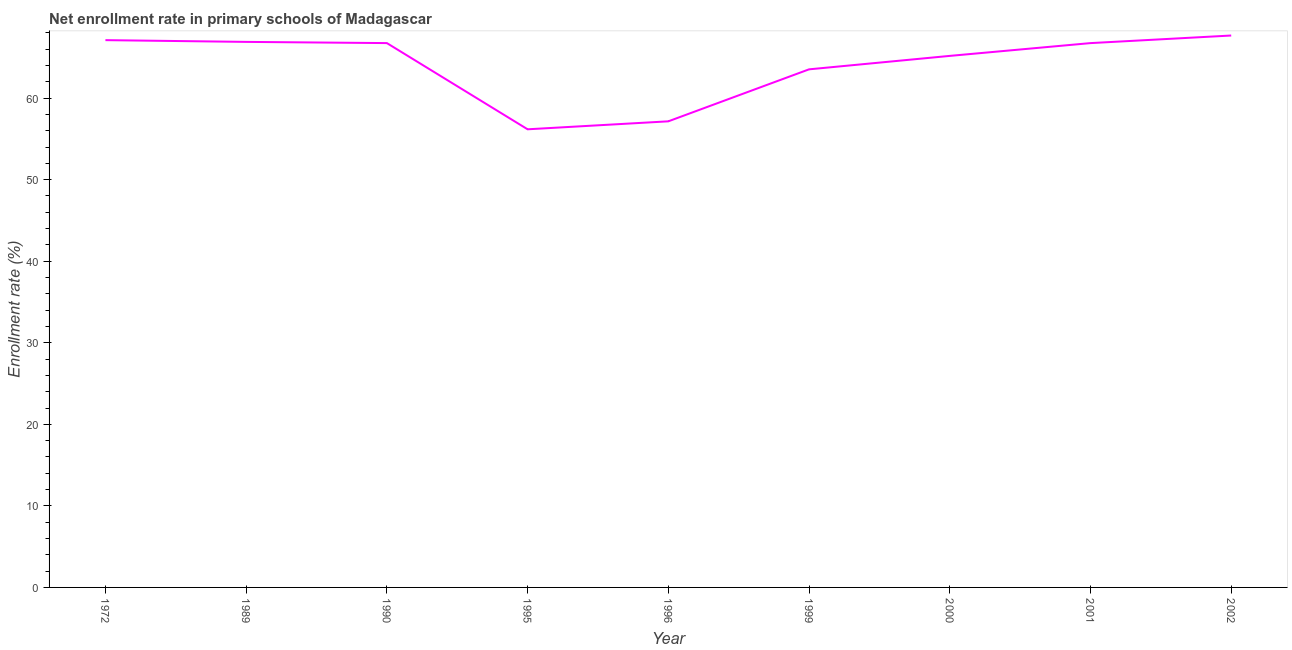What is the net enrollment rate in primary schools in 2001?
Keep it short and to the point. 66.75. Across all years, what is the maximum net enrollment rate in primary schools?
Keep it short and to the point. 67.68. Across all years, what is the minimum net enrollment rate in primary schools?
Provide a short and direct response. 56.18. What is the sum of the net enrollment rate in primary schools?
Provide a succinct answer. 577.24. What is the difference between the net enrollment rate in primary schools in 1990 and 2000?
Give a very brief answer. 1.57. What is the average net enrollment rate in primary schools per year?
Provide a short and direct response. 64.14. What is the median net enrollment rate in primary schools?
Your answer should be compact. 66.75. In how many years, is the net enrollment rate in primary schools greater than 10 %?
Offer a terse response. 9. Do a majority of the years between 2001 and 1999 (inclusive) have net enrollment rate in primary schools greater than 30 %?
Your response must be concise. No. What is the ratio of the net enrollment rate in primary schools in 1996 to that in 2000?
Make the answer very short. 0.88. What is the difference between the highest and the second highest net enrollment rate in primary schools?
Ensure brevity in your answer.  0.57. Is the sum of the net enrollment rate in primary schools in 1990 and 1999 greater than the maximum net enrollment rate in primary schools across all years?
Provide a short and direct response. Yes. What is the difference between the highest and the lowest net enrollment rate in primary schools?
Provide a succinct answer. 11.5. How many lines are there?
Your response must be concise. 1. How many years are there in the graph?
Offer a terse response. 9. Are the values on the major ticks of Y-axis written in scientific E-notation?
Ensure brevity in your answer.  No. Does the graph contain grids?
Keep it short and to the point. No. What is the title of the graph?
Give a very brief answer. Net enrollment rate in primary schools of Madagascar. What is the label or title of the X-axis?
Your answer should be compact. Year. What is the label or title of the Y-axis?
Give a very brief answer. Enrollment rate (%). What is the Enrollment rate (%) in 1972?
Your answer should be very brief. 67.11. What is the Enrollment rate (%) of 1989?
Your answer should be compact. 66.9. What is the Enrollment rate (%) of 1990?
Provide a succinct answer. 66.75. What is the Enrollment rate (%) in 1995?
Offer a very short reply. 56.18. What is the Enrollment rate (%) in 1996?
Make the answer very short. 57.16. What is the Enrollment rate (%) in 1999?
Provide a succinct answer. 63.53. What is the Enrollment rate (%) in 2000?
Give a very brief answer. 65.18. What is the Enrollment rate (%) of 2001?
Keep it short and to the point. 66.75. What is the Enrollment rate (%) in 2002?
Your response must be concise. 67.68. What is the difference between the Enrollment rate (%) in 1972 and 1989?
Provide a succinct answer. 0.21. What is the difference between the Enrollment rate (%) in 1972 and 1990?
Your response must be concise. 0.36. What is the difference between the Enrollment rate (%) in 1972 and 1995?
Your answer should be compact. 10.93. What is the difference between the Enrollment rate (%) in 1972 and 1996?
Provide a short and direct response. 9.95. What is the difference between the Enrollment rate (%) in 1972 and 1999?
Provide a succinct answer. 3.58. What is the difference between the Enrollment rate (%) in 1972 and 2000?
Provide a succinct answer. 1.93. What is the difference between the Enrollment rate (%) in 1972 and 2001?
Provide a short and direct response. 0.36. What is the difference between the Enrollment rate (%) in 1972 and 2002?
Make the answer very short. -0.57. What is the difference between the Enrollment rate (%) in 1989 and 1990?
Offer a terse response. 0.15. What is the difference between the Enrollment rate (%) in 1989 and 1995?
Your answer should be compact. 10.72. What is the difference between the Enrollment rate (%) in 1989 and 1996?
Offer a very short reply. 9.74. What is the difference between the Enrollment rate (%) in 1989 and 1999?
Offer a terse response. 3.37. What is the difference between the Enrollment rate (%) in 1989 and 2000?
Provide a short and direct response. 1.72. What is the difference between the Enrollment rate (%) in 1989 and 2001?
Offer a very short reply. 0.15. What is the difference between the Enrollment rate (%) in 1989 and 2002?
Offer a terse response. -0.78. What is the difference between the Enrollment rate (%) in 1990 and 1995?
Give a very brief answer. 10.57. What is the difference between the Enrollment rate (%) in 1990 and 1996?
Give a very brief answer. 9.59. What is the difference between the Enrollment rate (%) in 1990 and 1999?
Ensure brevity in your answer.  3.22. What is the difference between the Enrollment rate (%) in 1990 and 2000?
Make the answer very short. 1.57. What is the difference between the Enrollment rate (%) in 1990 and 2001?
Offer a terse response. 0. What is the difference between the Enrollment rate (%) in 1990 and 2002?
Your answer should be compact. -0.93. What is the difference between the Enrollment rate (%) in 1995 and 1996?
Give a very brief answer. -0.98. What is the difference between the Enrollment rate (%) in 1995 and 1999?
Your answer should be compact. -7.35. What is the difference between the Enrollment rate (%) in 1995 and 2000?
Offer a terse response. -9. What is the difference between the Enrollment rate (%) in 1995 and 2001?
Ensure brevity in your answer.  -10.57. What is the difference between the Enrollment rate (%) in 1995 and 2002?
Your response must be concise. -11.5. What is the difference between the Enrollment rate (%) in 1996 and 1999?
Your answer should be compact. -6.37. What is the difference between the Enrollment rate (%) in 1996 and 2000?
Provide a succinct answer. -8.02. What is the difference between the Enrollment rate (%) in 1996 and 2001?
Ensure brevity in your answer.  -9.59. What is the difference between the Enrollment rate (%) in 1996 and 2002?
Offer a terse response. -10.52. What is the difference between the Enrollment rate (%) in 1999 and 2000?
Make the answer very short. -1.65. What is the difference between the Enrollment rate (%) in 1999 and 2001?
Your response must be concise. -3.22. What is the difference between the Enrollment rate (%) in 1999 and 2002?
Provide a short and direct response. -4.15. What is the difference between the Enrollment rate (%) in 2000 and 2001?
Offer a very short reply. -1.57. What is the difference between the Enrollment rate (%) in 2000 and 2002?
Make the answer very short. -2.5. What is the difference between the Enrollment rate (%) in 2001 and 2002?
Provide a short and direct response. -0.93. What is the ratio of the Enrollment rate (%) in 1972 to that in 1989?
Offer a very short reply. 1. What is the ratio of the Enrollment rate (%) in 1972 to that in 1995?
Keep it short and to the point. 1.2. What is the ratio of the Enrollment rate (%) in 1972 to that in 1996?
Your response must be concise. 1.17. What is the ratio of the Enrollment rate (%) in 1972 to that in 1999?
Provide a succinct answer. 1.06. What is the ratio of the Enrollment rate (%) in 1972 to that in 2000?
Keep it short and to the point. 1.03. What is the ratio of the Enrollment rate (%) in 1972 to that in 2001?
Provide a short and direct response. 1. What is the ratio of the Enrollment rate (%) in 1972 to that in 2002?
Make the answer very short. 0.99. What is the ratio of the Enrollment rate (%) in 1989 to that in 1995?
Offer a very short reply. 1.19. What is the ratio of the Enrollment rate (%) in 1989 to that in 1996?
Offer a terse response. 1.17. What is the ratio of the Enrollment rate (%) in 1989 to that in 1999?
Ensure brevity in your answer.  1.05. What is the ratio of the Enrollment rate (%) in 1989 to that in 2000?
Your response must be concise. 1.03. What is the ratio of the Enrollment rate (%) in 1989 to that in 2001?
Offer a very short reply. 1. What is the ratio of the Enrollment rate (%) in 1990 to that in 1995?
Your response must be concise. 1.19. What is the ratio of the Enrollment rate (%) in 1990 to that in 1996?
Your answer should be compact. 1.17. What is the ratio of the Enrollment rate (%) in 1990 to that in 1999?
Your answer should be very brief. 1.05. What is the ratio of the Enrollment rate (%) in 1990 to that in 2001?
Your answer should be compact. 1. What is the ratio of the Enrollment rate (%) in 1995 to that in 1996?
Provide a short and direct response. 0.98. What is the ratio of the Enrollment rate (%) in 1995 to that in 1999?
Offer a terse response. 0.88. What is the ratio of the Enrollment rate (%) in 1995 to that in 2000?
Offer a very short reply. 0.86. What is the ratio of the Enrollment rate (%) in 1995 to that in 2001?
Offer a very short reply. 0.84. What is the ratio of the Enrollment rate (%) in 1995 to that in 2002?
Keep it short and to the point. 0.83. What is the ratio of the Enrollment rate (%) in 1996 to that in 2000?
Keep it short and to the point. 0.88. What is the ratio of the Enrollment rate (%) in 1996 to that in 2001?
Keep it short and to the point. 0.86. What is the ratio of the Enrollment rate (%) in 1996 to that in 2002?
Offer a terse response. 0.84. What is the ratio of the Enrollment rate (%) in 1999 to that in 2002?
Your answer should be compact. 0.94. What is the ratio of the Enrollment rate (%) in 2000 to that in 2002?
Your response must be concise. 0.96. 